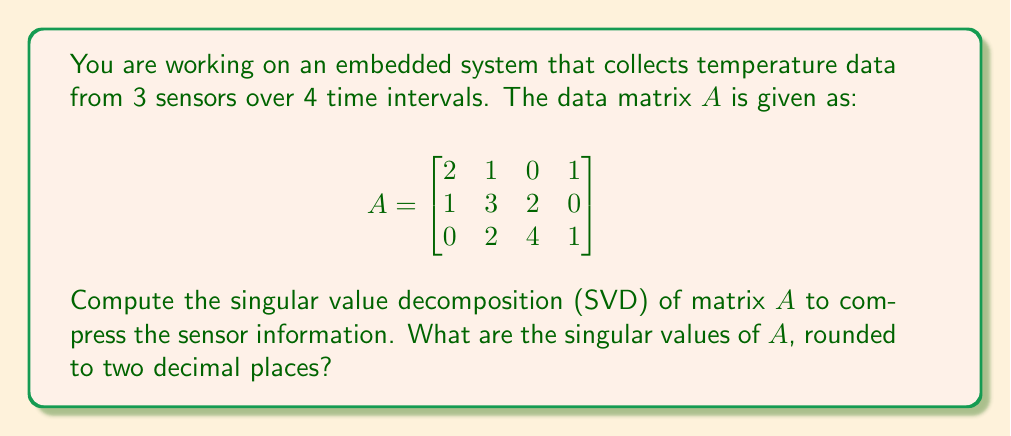Help me with this question. To find the singular value decomposition of matrix $A$, we need to follow these steps:

1) First, compute $A^TA$:
   $$A^TA = \begin{bmatrix}
   2 & 1 & 0 \\
   1 & 3 & 2 \\
   0 & 2 & 4 \\
   1 & 0 & 1
   \end{bmatrix} \begin{bmatrix}
   2 & 1 & 0 & 1 \\
   1 & 3 & 2 & 0 \\
   0 & 2 & 4 & 1
   \end{bmatrix} = \begin{bmatrix}
   5 & 7 & 4 & 2 \\
   7 & 14 & 10 & 3 \\
   4 & 10 & 24 & 4 \\
   2 & 3 & 4 & 2
   \end{bmatrix}$$

2) Find the eigenvalues of $A^TA$ by solving the characteristic equation:
   $\det(A^TA - \lambda I) = 0$

3) The eigenvalues are the roots of this equation. Using a calculator or computer algebra system, we find:
   $\lambda_1 \approx 30.7439$
   $\lambda_2 \approx 12.8984$
   $\lambda_3 \approx 1.3577$
   $\lambda_4 = 0$

4) The singular values are the square roots of these eigenvalues:
   $\sigma_1 = \sqrt{30.7439} \approx 5.54$
   $\sigma_2 = \sqrt{12.8984} \approx 3.59$
   $\sigma_3 = \sqrt{1.3577} \approx 1.17$
   $\sigma_4 = \sqrt{0} = 0$

5) Rounding to two decimal places, we get the final answer.
Answer: $\sigma_1 \approx 5.54$, $\sigma_2 \approx 3.59$, $\sigma_3 \approx 1.17$ 